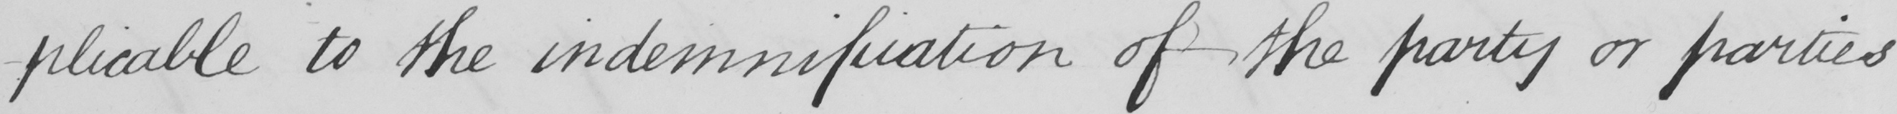Please transcribe the handwritten text in this image. -plicable to the indemnification of the party or parties 